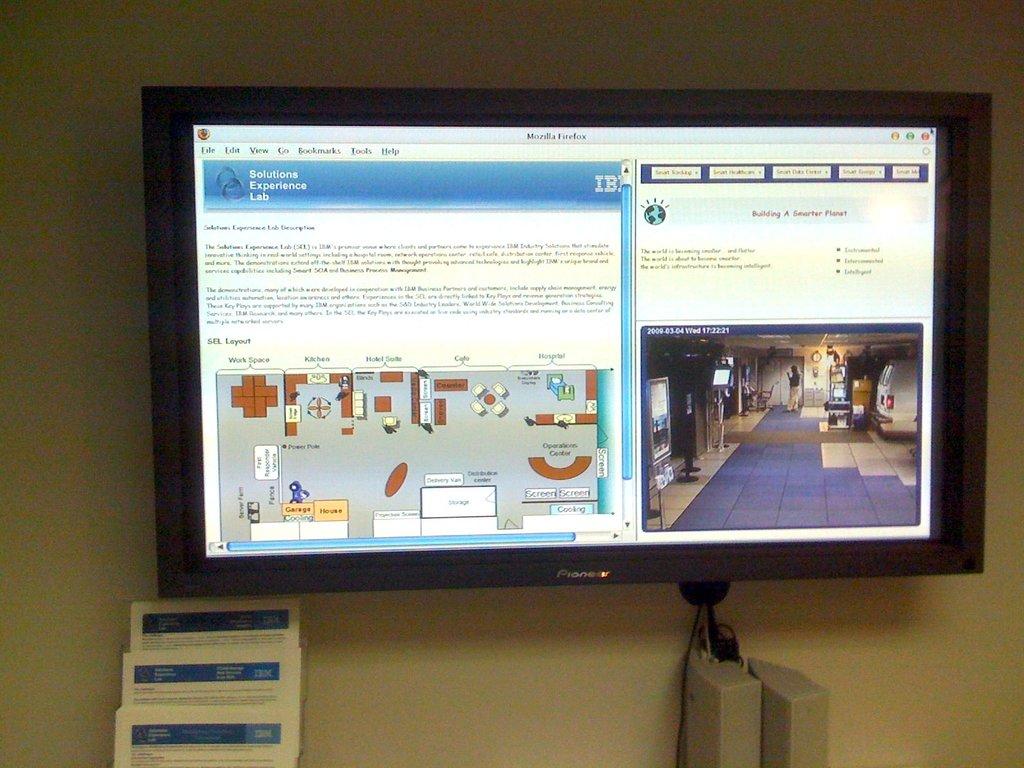Is the computer in a lab?
Keep it short and to the point. Unanswerable. Is there a layout on the screen?
Give a very brief answer. Answering does not require reading text in the image. 